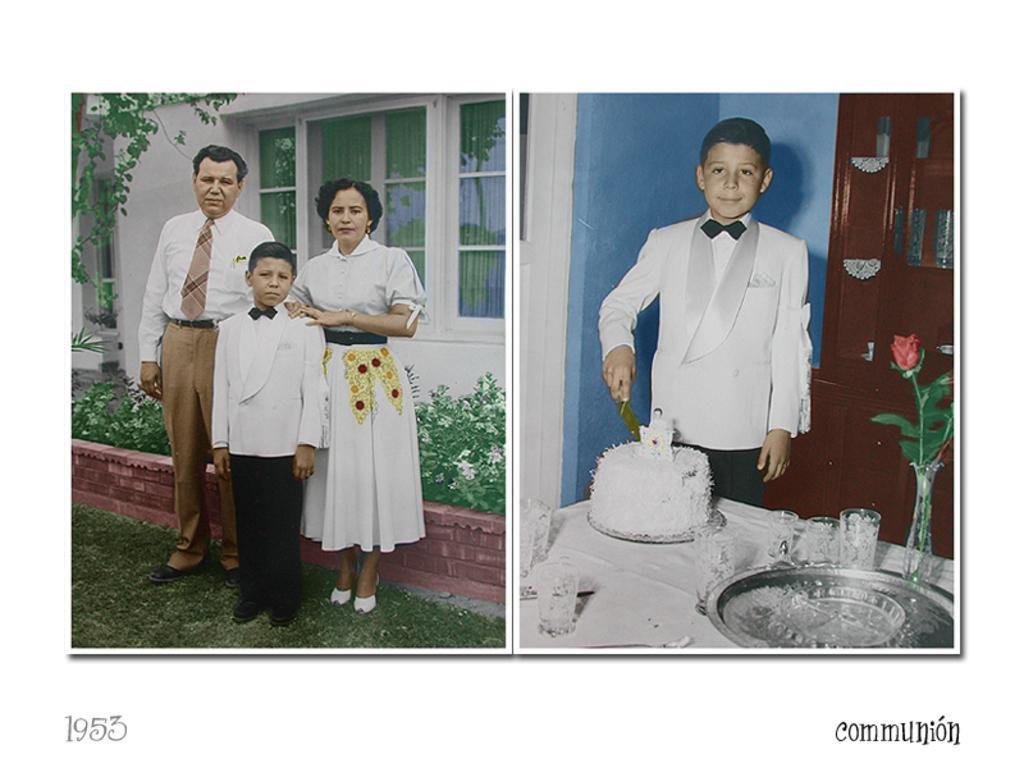Please provide a concise description of this image. This is a collage image. In the first image there are three people standing on the grass, behind them there are a few plants and a building. In the second image there is a boy standing and holding a knife, in front of him there is a table, on which there is a cake, glass, plate, flower vase and in the background there is a wall and a cupboard. 